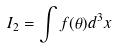Convert formula to latex. <formula><loc_0><loc_0><loc_500><loc_500>I _ { 2 } = \int f ( \theta ) d ^ { 3 } x</formula> 